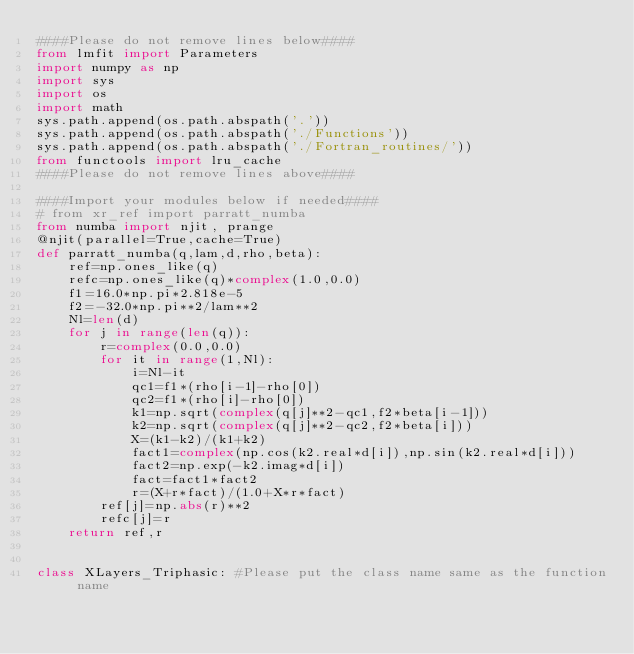<code> <loc_0><loc_0><loc_500><loc_500><_Python_>####Please do not remove lines below####
from lmfit import Parameters
import numpy as np
import sys
import os
import math
sys.path.append(os.path.abspath('.'))
sys.path.append(os.path.abspath('./Functions'))
sys.path.append(os.path.abspath('./Fortran_routines/'))
from functools import lru_cache
####Please do not remove lines above####

####Import your modules below if needed####
# from xr_ref import parratt_numba
from numba import njit, prange
@njit(parallel=True,cache=True)
def parratt_numba(q,lam,d,rho,beta):
    ref=np.ones_like(q)
    refc=np.ones_like(q)*complex(1.0,0.0)
    f1=16.0*np.pi*2.818e-5
    f2=-32.0*np.pi**2/lam**2
    Nl=len(d)
    for j in range(len(q)):
        r=complex(0.0,0.0)
        for it in range(1,Nl):
            i=Nl-it
            qc1=f1*(rho[i-1]-rho[0])
            qc2=f1*(rho[i]-rho[0])
            k1=np.sqrt(complex(q[j]**2-qc1,f2*beta[i-1]))
            k2=np.sqrt(complex(q[j]**2-qc2,f2*beta[i]))
            X=(k1-k2)/(k1+k2)
            fact1=complex(np.cos(k2.real*d[i]),np.sin(k2.real*d[i]))
            fact2=np.exp(-k2.imag*d[i])
            fact=fact1*fact2
            r=(X+r*fact)/(1.0+X*r*fact)
        ref[j]=np.abs(r)**2
        refc[j]=r
    return ref,r


class XLayers_Triphasic: #Please put the class name same as the function name</code> 